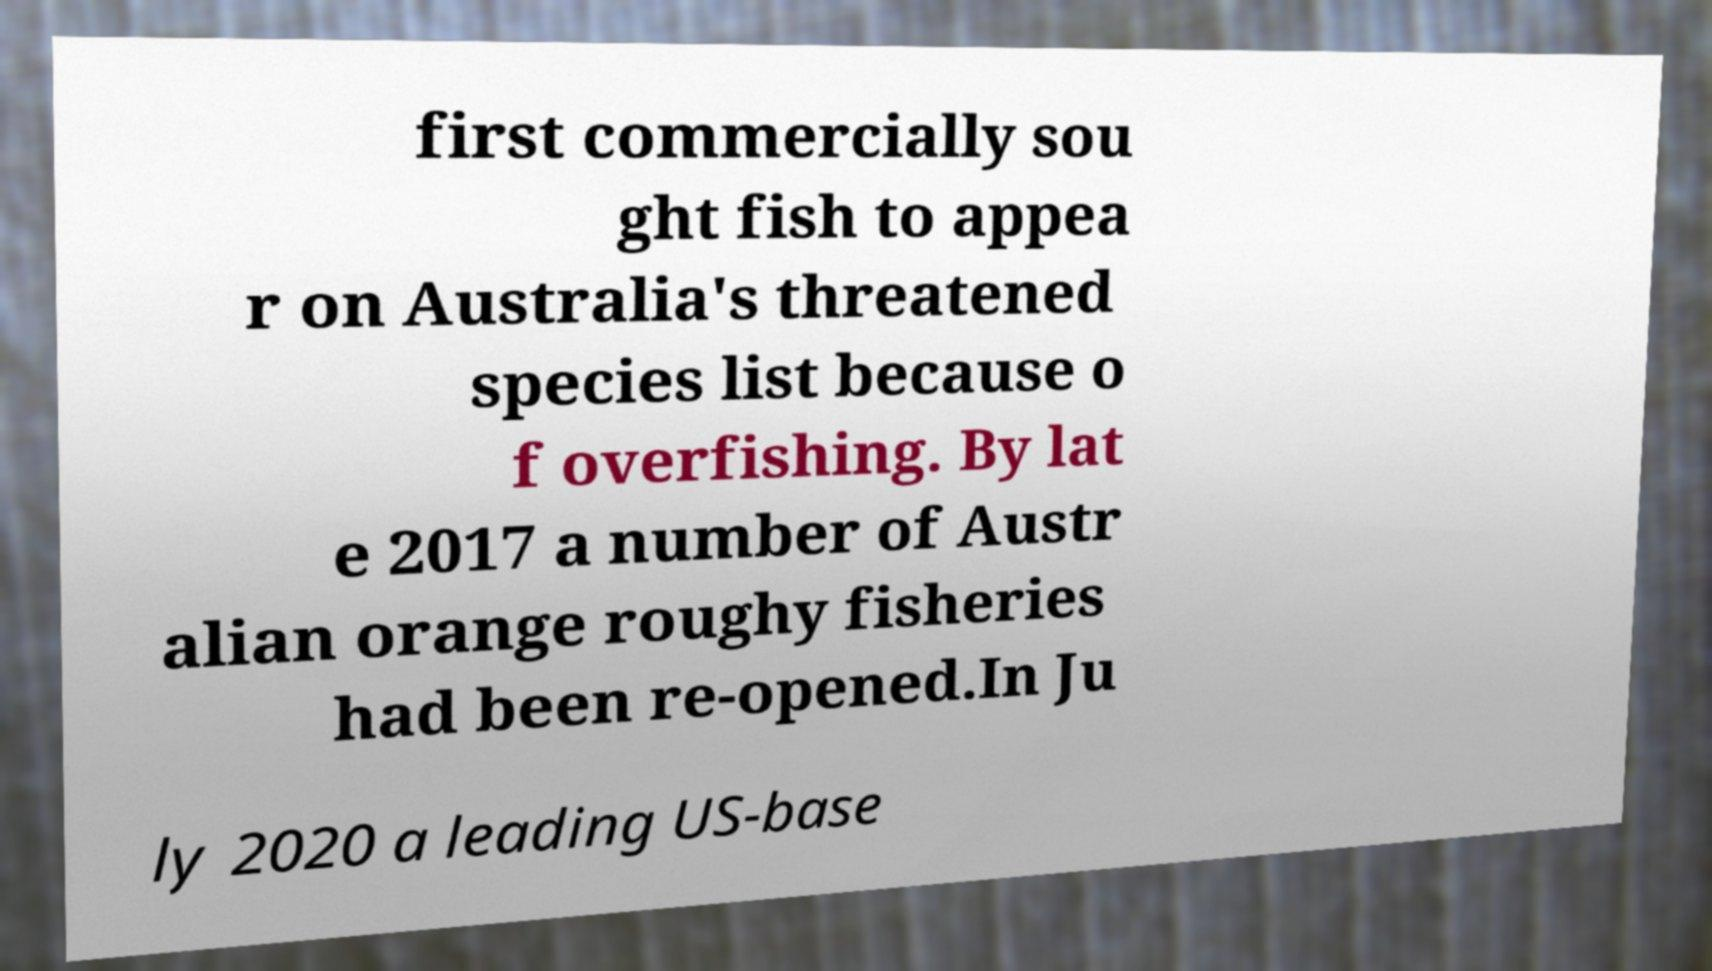Can you accurately transcribe the text from the provided image for me? first commercially sou ght fish to appea r on Australia's threatened species list because o f overfishing. By lat e 2017 a number of Austr alian orange roughy fisheries had been re-opened.In Ju ly 2020 a leading US-base 